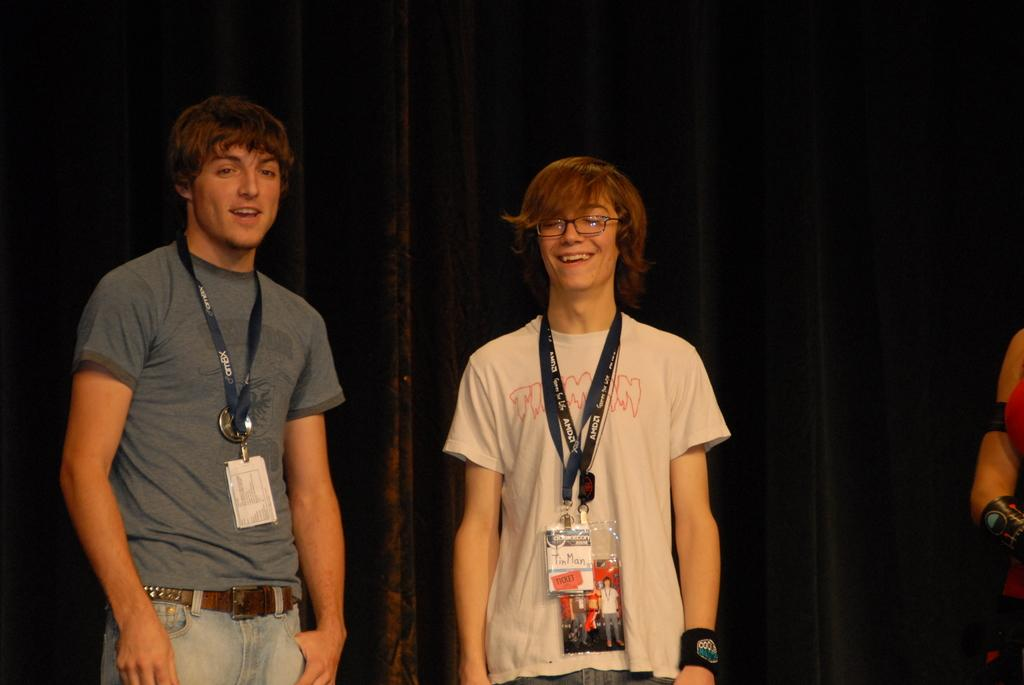How many boys are in the image? There are two boys in the image. What are the boys wearing in the image? Both boys are wearing access cards. What type of object can be seen on the right side of the image? There is a curtain visible in the image. Can you describe the appearance of the person on the right side of the image? There is a truncated person on the right side of the image. What type of jelly is being served at the argument between the boys in the image? There is no jelly or argument present in the image. How many pies are visible on the table in the image? There is no table or pies present in the image. 